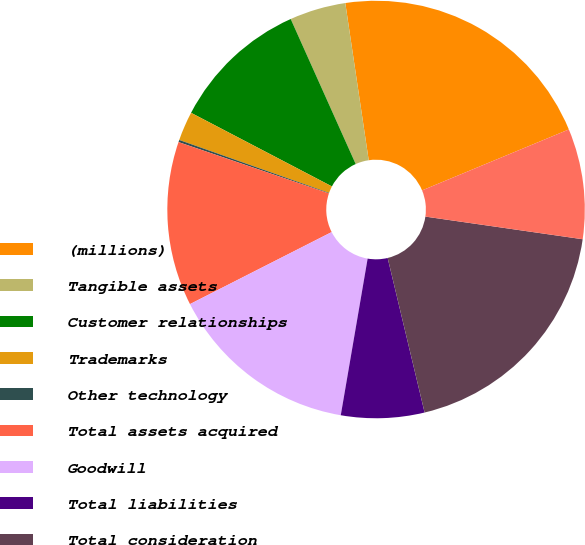<chart> <loc_0><loc_0><loc_500><loc_500><pie_chart><fcel>(millions)<fcel>Tangible assets<fcel>Customer relationships<fcel>Trademarks<fcel>Other technology<fcel>Total assets acquired<fcel>Goodwill<fcel>Total liabilities<fcel>Total consideration<fcel>Long-term debt repaid upon<nl><fcel>21.09%<fcel>4.35%<fcel>10.63%<fcel>2.26%<fcel>0.17%<fcel>12.72%<fcel>14.81%<fcel>6.44%<fcel>18.99%<fcel>8.54%<nl></chart> 